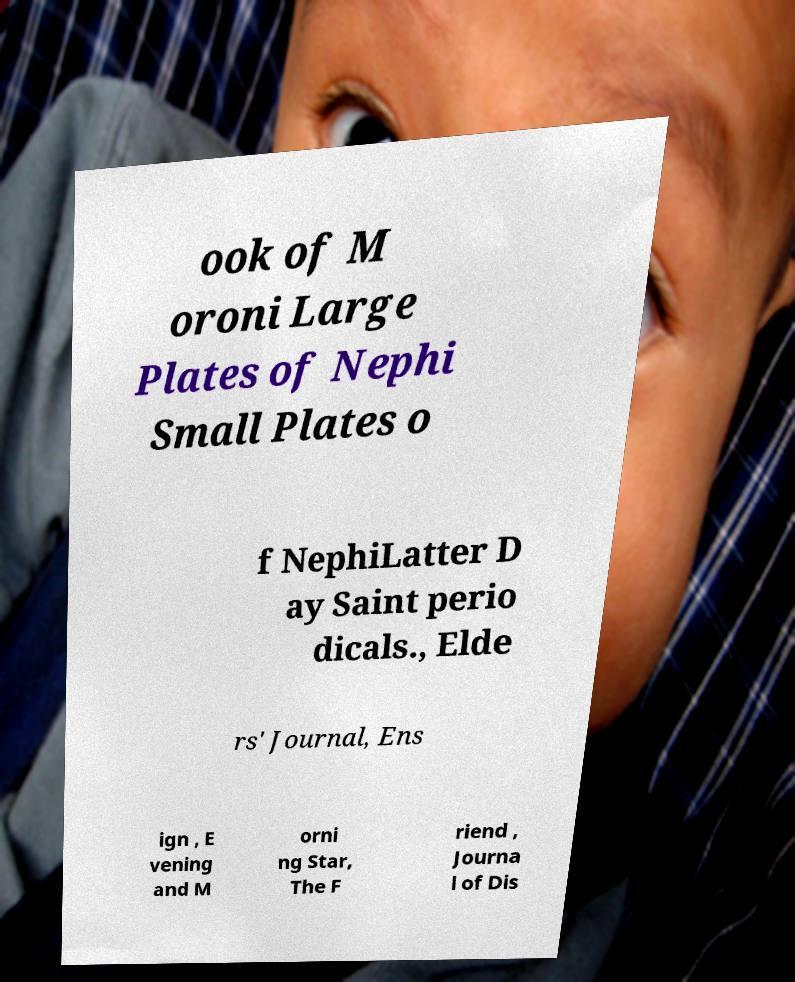For documentation purposes, I need the text within this image transcribed. Could you provide that? ook of M oroni Large Plates of Nephi Small Plates o f NephiLatter D ay Saint perio dicals., Elde rs' Journal, Ens ign , E vening and M orni ng Star, The F riend , Journa l of Dis 